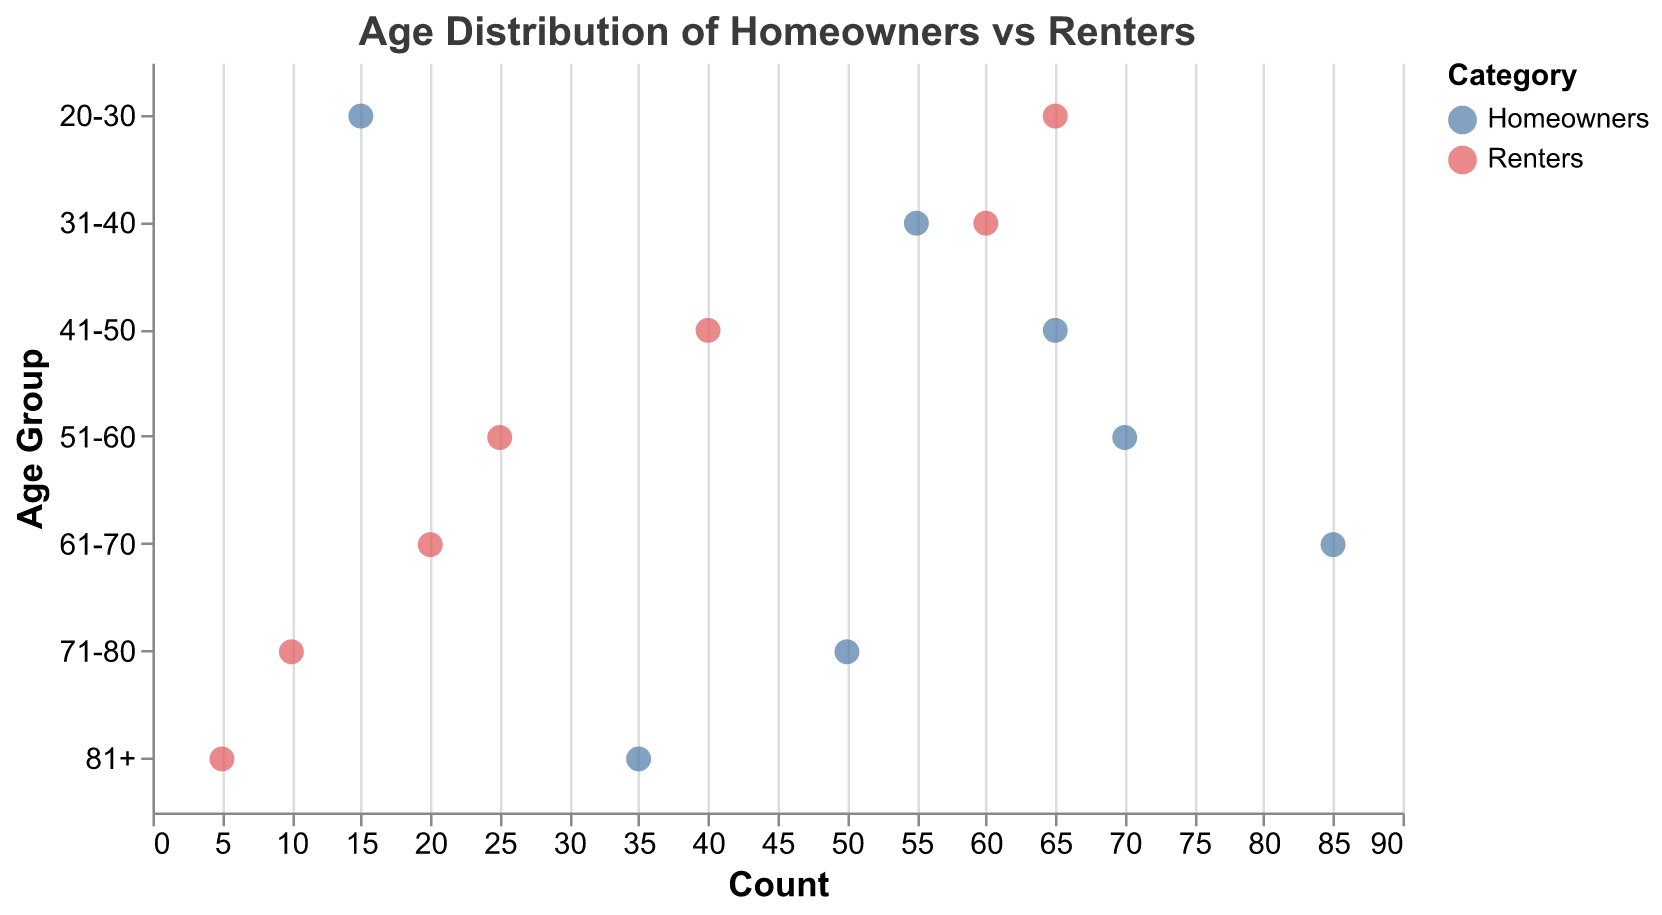What is the title of the figure? The title is usually placed at the top of the figure. Here, you can see "Age Distribution of Homeowners vs Renters" at the top.
Answer: Age Distribution of Homeowners vs Renters Which age group has the highest count of homeowners? Look at the 'Homeowners' category and find the age group with the highest count. The '61-70' age group has the highest count of homeowners (85).
Answer: '61-70' How many renters are there in the '20-30' age group? Look at the data points for the 'Renters' category in the age group '20-30'. The dot positioned at '65' on the x-axis indicates there are 65 renters.
Answer: 65 What is the total count of homeowners aged 51-60 and 61-70? Sum the counts of homeowners in the '51-60' (70) and '61-70' (85) age groups: 70 + 85 = 155.
Answer: 155 Which age group has a greater difference between homeowners and renters? Subtract the counts for each age group and identify the largest difference. The '61-70' age group shows the greatest difference: 85 (homeowners) - 20 (renters) = 65.
Answer: '61-70' What is the general trend of the homeowner's age distribution as age increases? The count of homeowners tends to increase with age, peaking in the '61-70' age group, then it starts to decline after '70-80'.
Answer: Increase then decline What is the minimum count for renters across all age groups? Look at the lowest point in the renters' category data points. The minimum count is 5 in the '81+' age group.
Answer: 5 How do the counts of homeowners and renters in the '31-40' age group compare? For '31-40', homeowners have a count of 55, and renters have a count of 60. Therefore, renters have a higher count than homeowners in this age group.
Answer: Renters have a higher count What's the combined average count of homeowners and renters aged '20-30'? First, calculate the combined count: 15 (homeowners) + 65 (renters) = 80. Then find the average: 80 / 2 = 40.
Answer: 40 What trend emerges when comparing the renter counts across increasing age groups? As age increases, the count of renters decreases consistently from 65 (20-30) to 5 ('81+').
Answer: Decreasing 